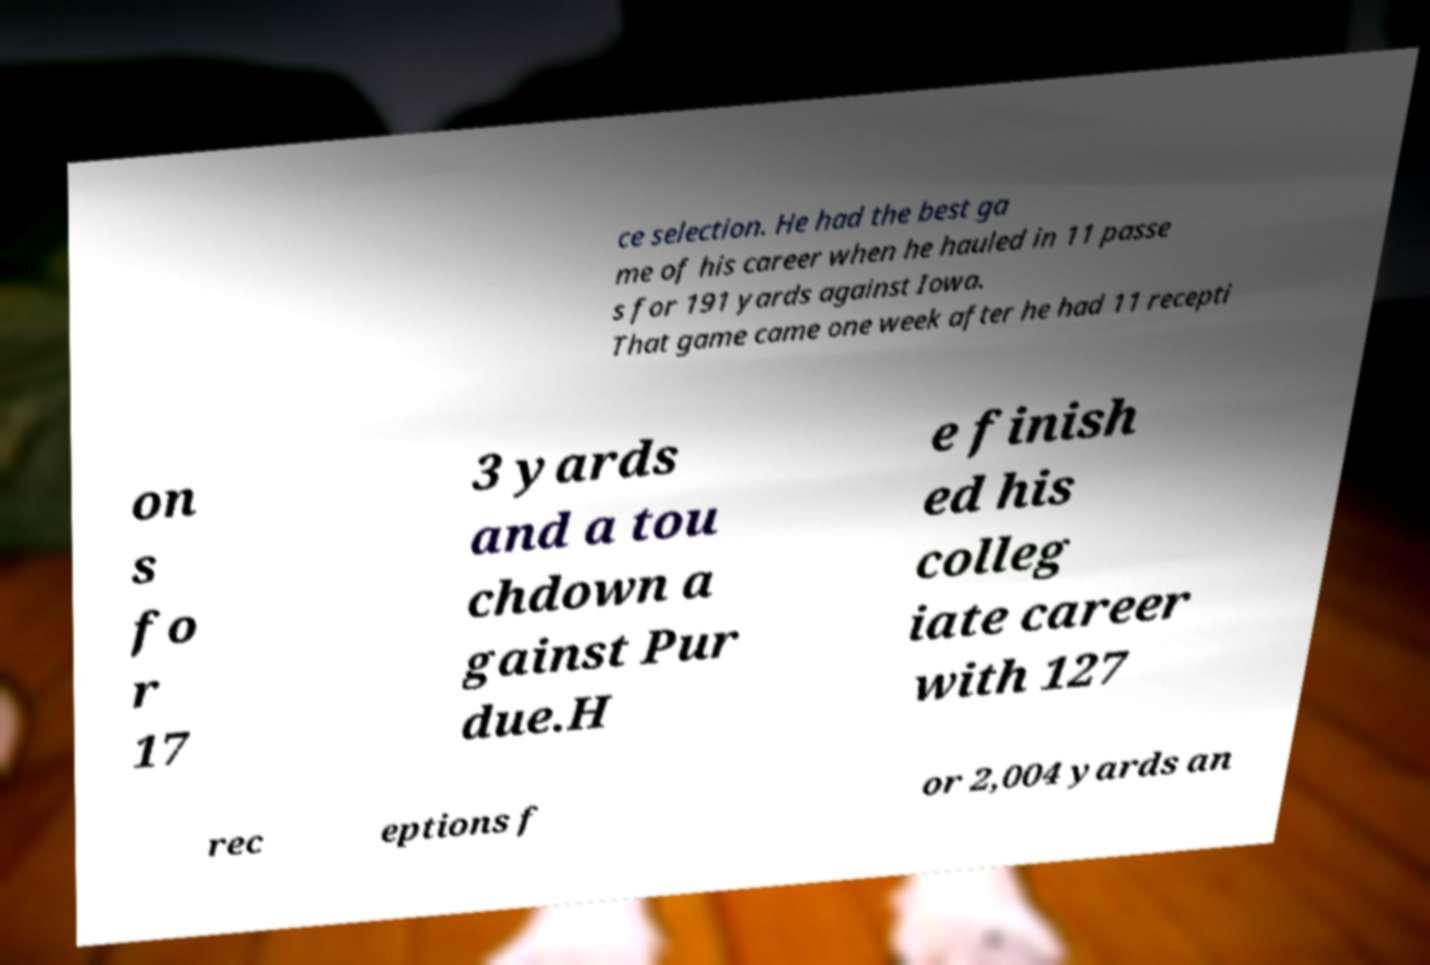What messages or text are displayed in this image? I need them in a readable, typed format. ce selection. He had the best ga me of his career when he hauled in 11 passe s for 191 yards against Iowa. That game came one week after he had 11 recepti on s fo r 17 3 yards and a tou chdown a gainst Pur due.H e finish ed his colleg iate career with 127 rec eptions f or 2,004 yards an 